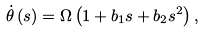Convert formula to latex. <formula><loc_0><loc_0><loc_500><loc_500>\dot { \theta } \left ( s \right ) = \Omega \left ( 1 + b _ { 1 } s + b _ { 2 } s ^ { 2 } \right ) ,</formula> 